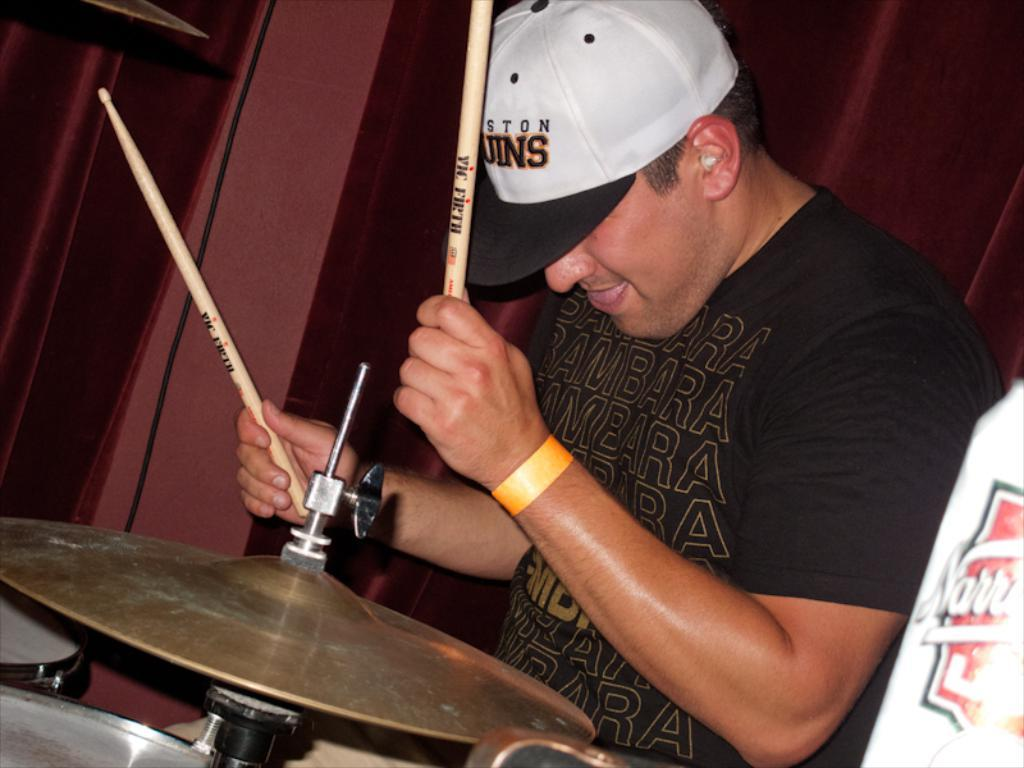<image>
Summarize the visual content of the image. A man is playing with drumsticks that have the word "vic" on them. 